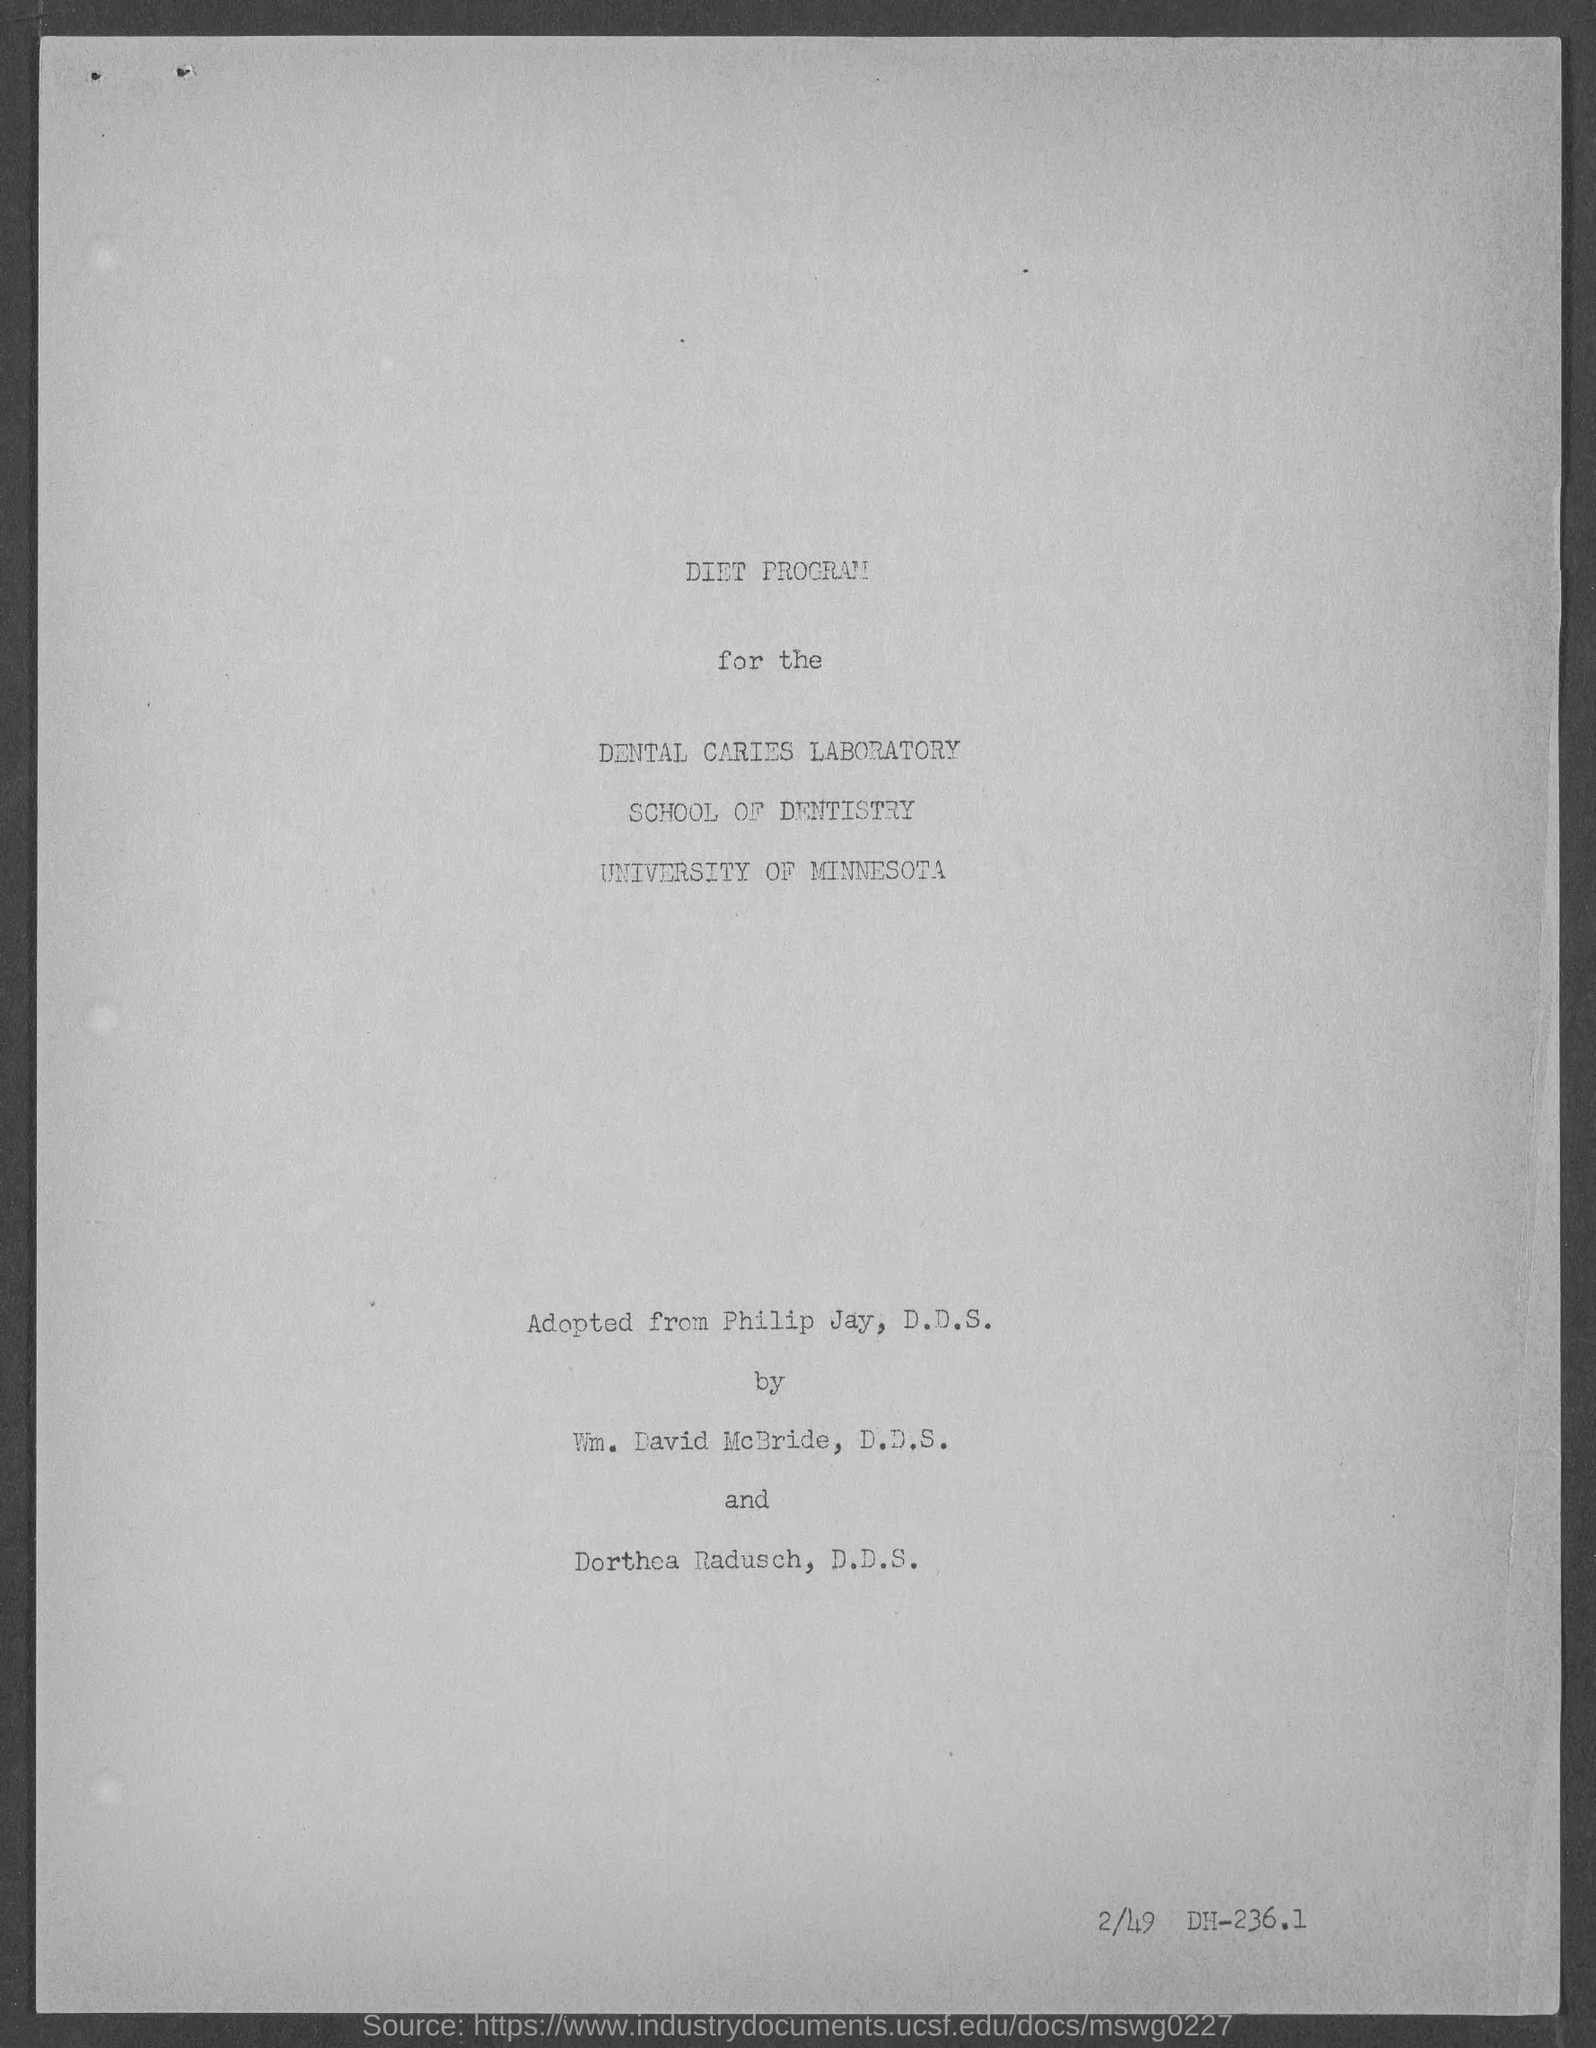Which school comes under "University of Minnesota"?
Offer a very short reply. SCHOOL OF DENTISTRY. What is written in the bottom right side ?
Give a very brief answer. 2/49 DH-236.1. 